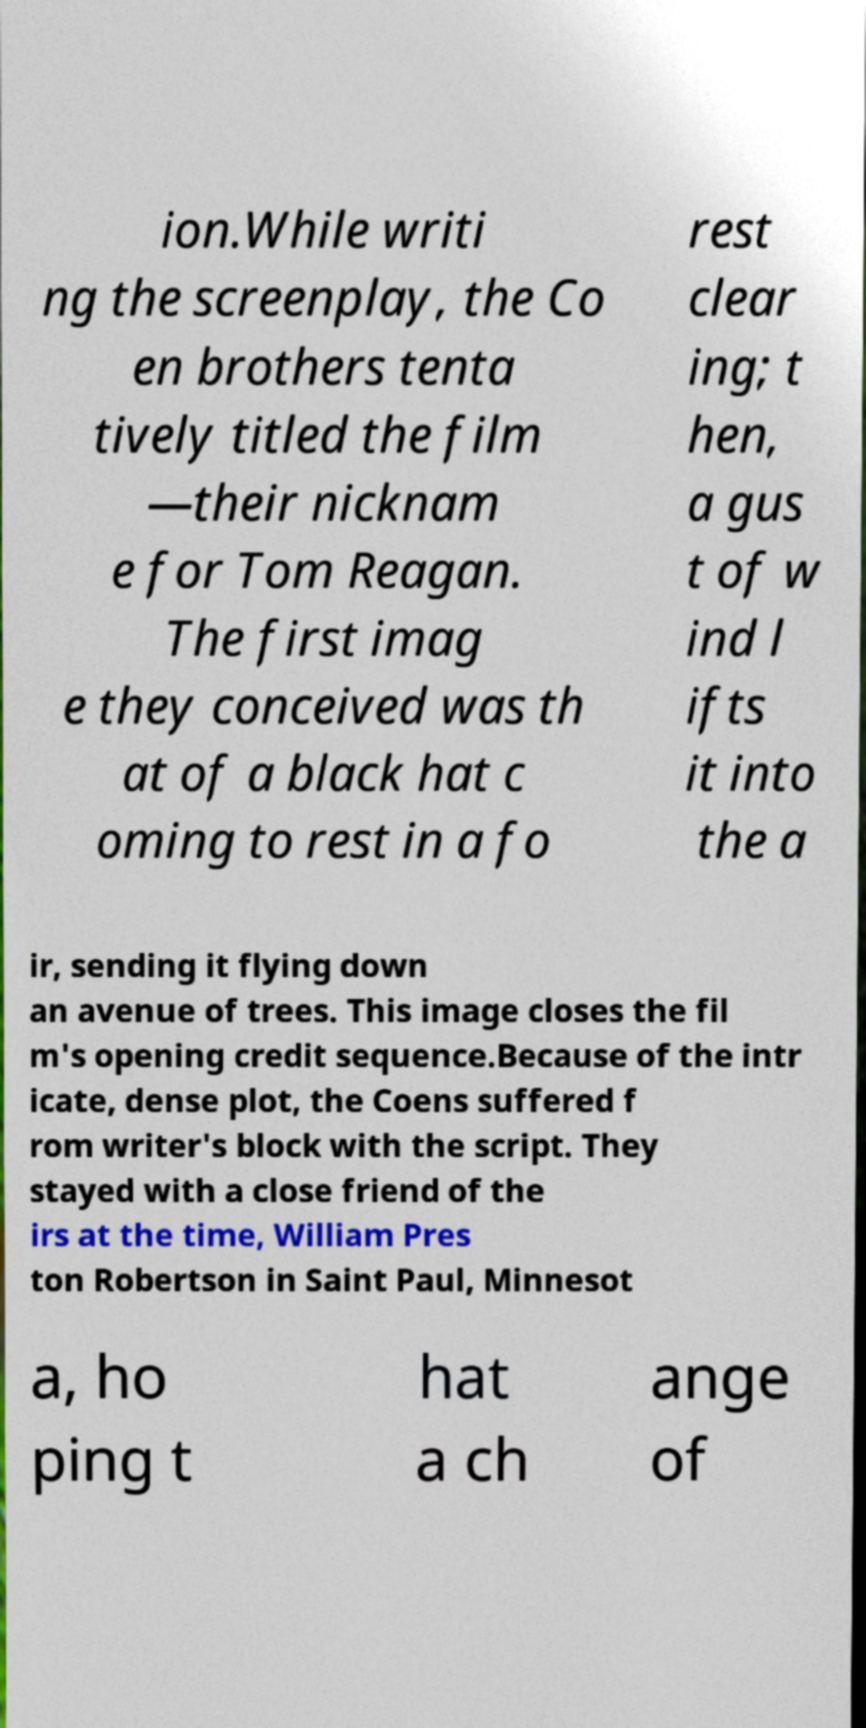Can you read and provide the text displayed in the image?This photo seems to have some interesting text. Can you extract and type it out for me? ion.While writi ng the screenplay, the Co en brothers tenta tively titled the film —their nicknam e for Tom Reagan. The first imag e they conceived was th at of a black hat c oming to rest in a fo rest clear ing; t hen, a gus t of w ind l ifts it into the a ir, sending it flying down an avenue of trees. This image closes the fil m's opening credit sequence.Because of the intr icate, dense plot, the Coens suffered f rom writer's block with the script. They stayed with a close friend of the irs at the time, William Pres ton Robertson in Saint Paul, Minnesot a, ho ping t hat a ch ange of 